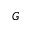<formula> <loc_0><loc_0><loc_500><loc_500>G</formula> 